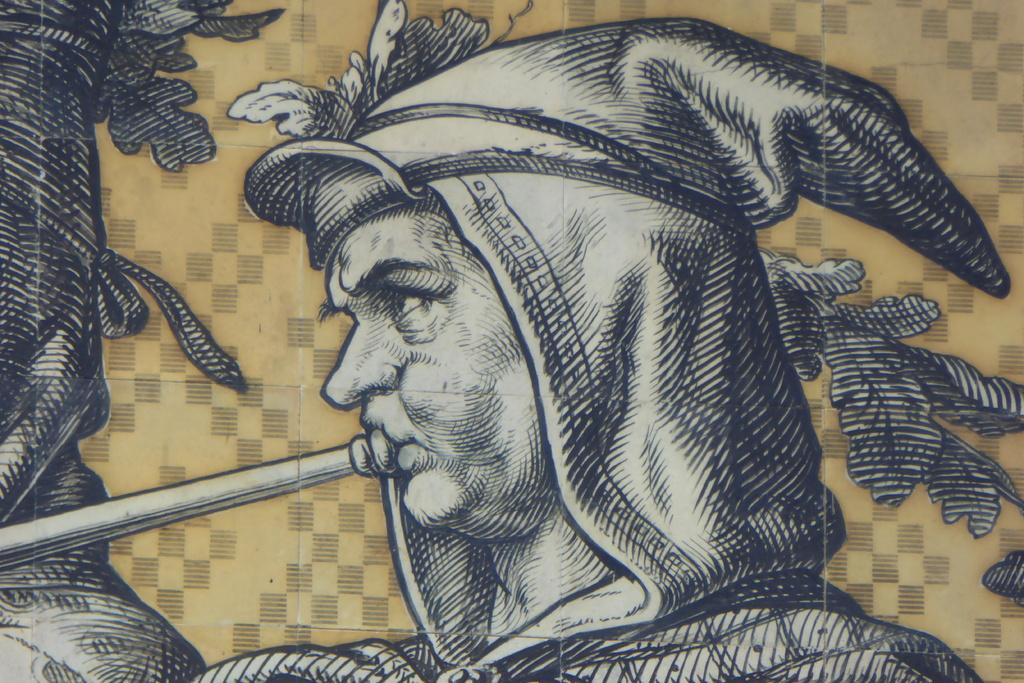Who or what is the main subject in the image? There is a person present in the image. What is the person wearing on their head? The person is wearing a cap attached to their dress. What is the person doing in the image? The person is playing a musical instrument. Can you describe the art in the image? Unfortunately, the facts provided do not give any details about the art in the image. What is the color of the background in the image? The background of the image is creamy in color. Is the person driving a car in the image? No, there is no car or driving activity present in the image. What type of stitch is used to attach the cap to the dress? The facts provided do not give any information about the type of stitch used to attach the cap to the dress. 